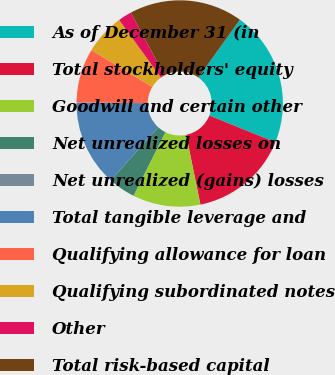<chart> <loc_0><loc_0><loc_500><loc_500><pie_chart><fcel>As of December 31 (in<fcel>Total stockholders' equity<fcel>Goodwill and certain other<fcel>Net unrealized losses on<fcel>Net unrealized (gains) losses<fcel>Total tangible leverage and<fcel>Qualifying allowance for loan<fcel>Qualifying subordinated notes<fcel>Other<fcel>Total risk-based capital<nl><fcel>21.22%<fcel>15.65%<fcel>10.61%<fcel>4.25%<fcel>0.0%<fcel>13.52%<fcel>8.49%<fcel>6.37%<fcel>2.12%<fcel>17.77%<nl></chart> 